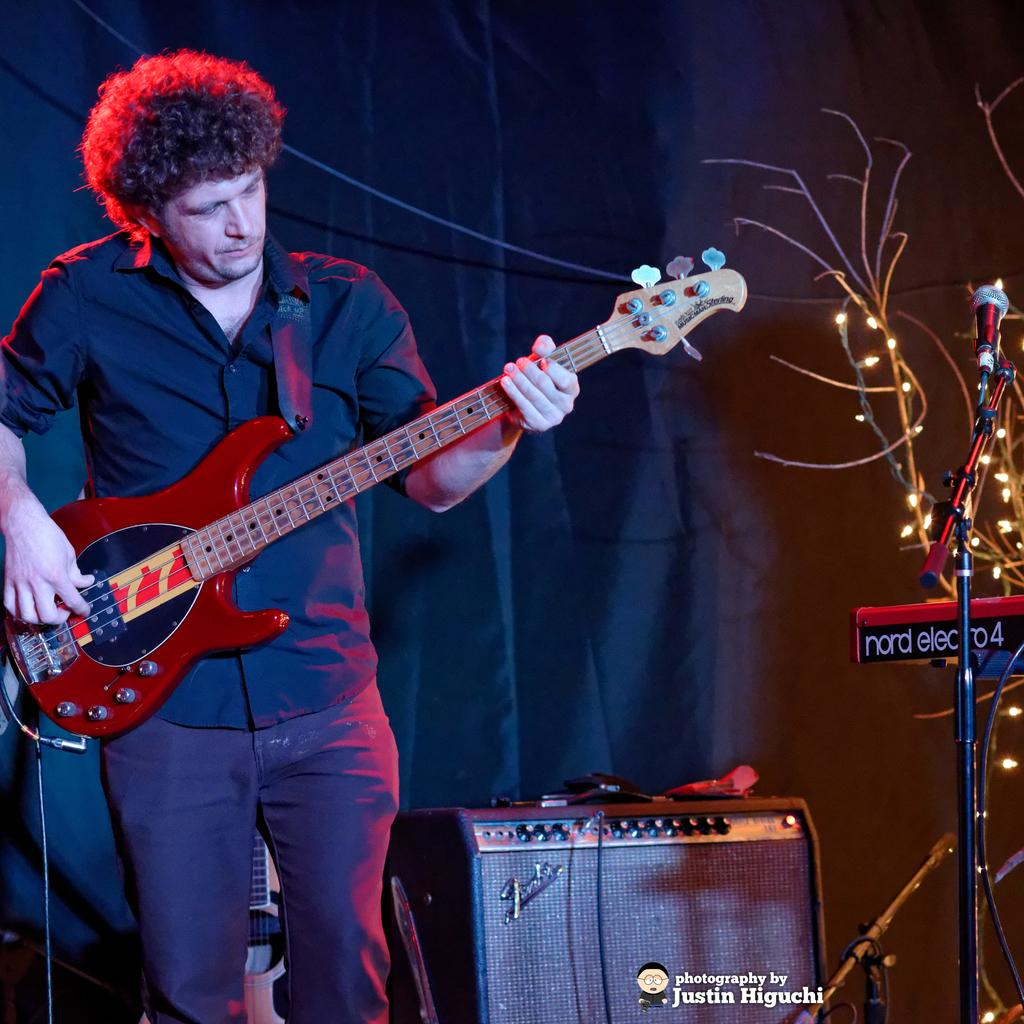What is the man in the image doing? The man is playing a guitar in the image. Where is the man located in the image? The man is located in the left side corner of the image. What other object can be seen in the image besides the guitar? There is a microphone in the image. Where is the microphone located in the image? The microphone is located on the right side of the image. What can be seen in the background of the image? There is a curtain in the background of the image. What type of hammer is the man using to play the guitar in the image? There is no hammer present in the image; the man is playing the guitar with his hands. What is the position of the sun in the image? The sun is not visible in the image, so its position cannot be determined. 